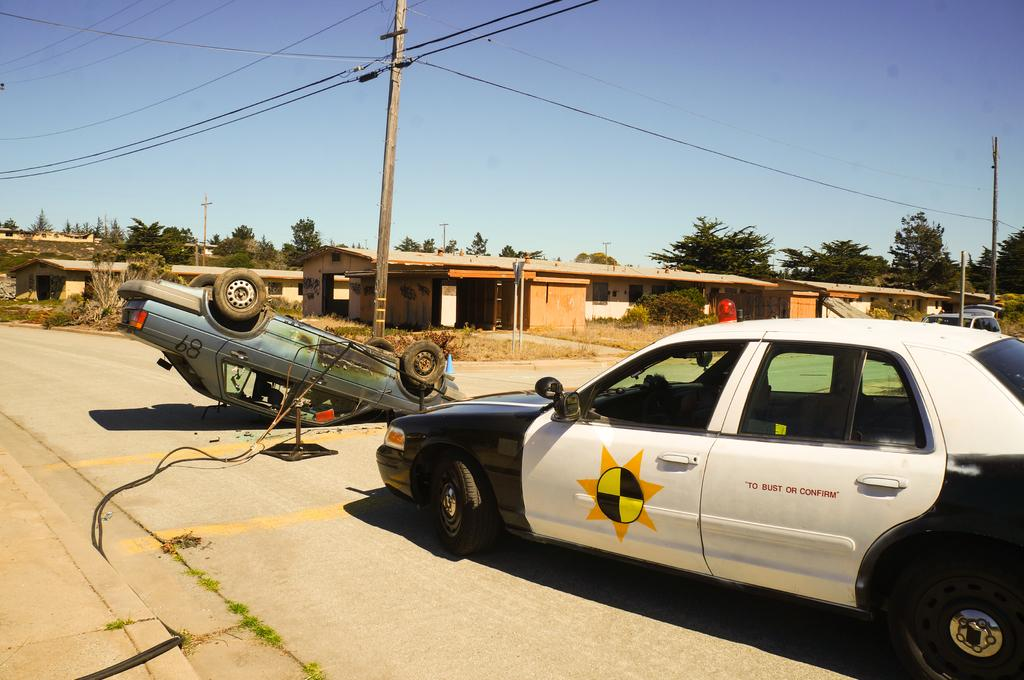<image>
Give a short and clear explanation of the subsequent image. A car with "To bust or confirm" on the side is sitting in front of a car that 